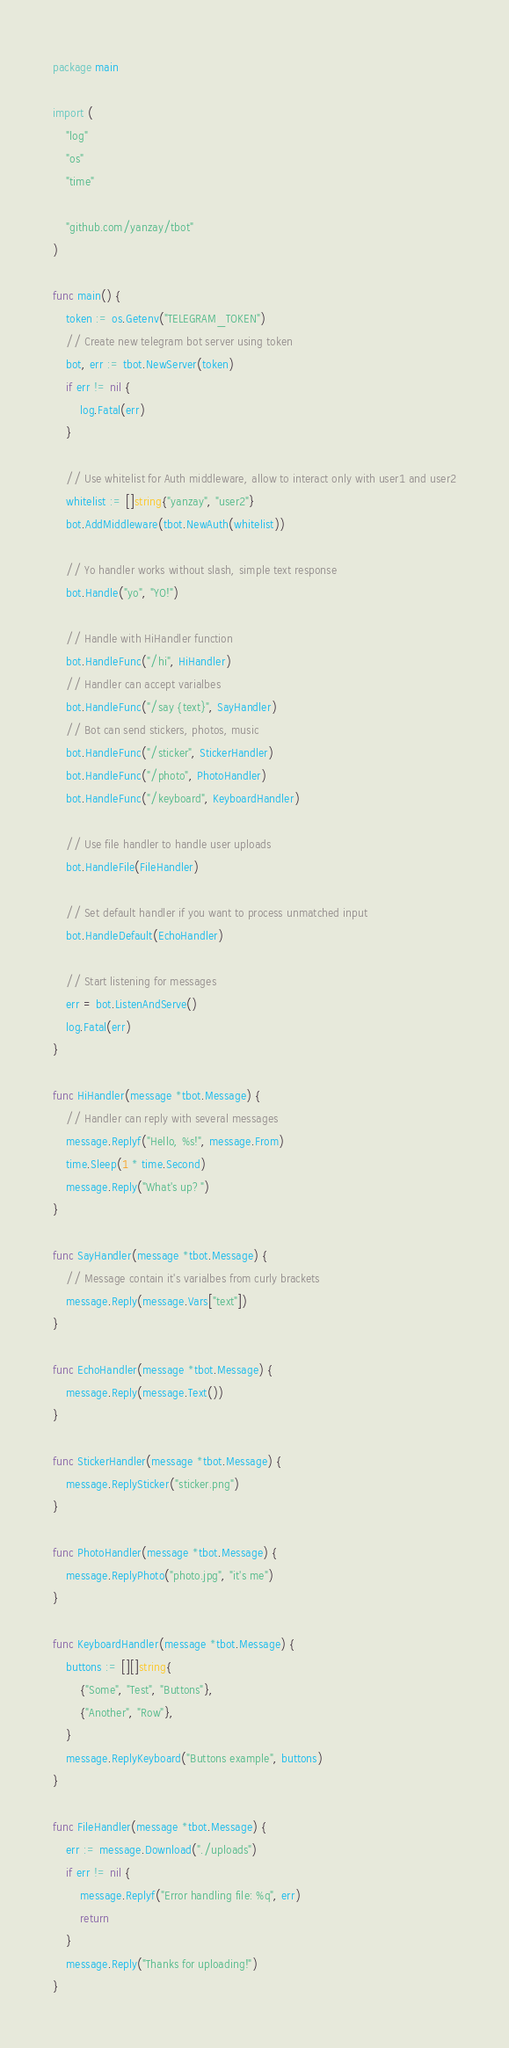Convert code to text. <code><loc_0><loc_0><loc_500><loc_500><_Go_>package main

import (
	"log"
	"os"
	"time"

	"github.com/yanzay/tbot"
)

func main() {
	token := os.Getenv("TELEGRAM_TOKEN")
	// Create new telegram bot server using token
	bot, err := tbot.NewServer(token)
	if err != nil {
		log.Fatal(err)
	}

	// Use whitelist for Auth middleware, allow to interact only with user1 and user2
	whitelist := []string{"yanzay", "user2"}
	bot.AddMiddleware(tbot.NewAuth(whitelist))

	// Yo handler works without slash, simple text response
	bot.Handle("yo", "YO!")

	// Handle with HiHandler function
	bot.HandleFunc("/hi", HiHandler)
	// Handler can accept varialbes
	bot.HandleFunc("/say {text}", SayHandler)
	// Bot can send stickers, photos, music
	bot.HandleFunc("/sticker", StickerHandler)
	bot.HandleFunc("/photo", PhotoHandler)
	bot.HandleFunc("/keyboard", KeyboardHandler)

	// Use file handler to handle user uploads
	bot.HandleFile(FileHandler)

	// Set default handler if you want to process unmatched input
	bot.HandleDefault(EchoHandler)

	// Start listening for messages
	err = bot.ListenAndServe()
	log.Fatal(err)
}

func HiHandler(message *tbot.Message) {
	// Handler can reply with several messages
	message.Replyf("Hello, %s!", message.From)
	time.Sleep(1 * time.Second)
	message.Reply("What's up?")
}

func SayHandler(message *tbot.Message) {
	// Message contain it's varialbes from curly brackets
	message.Reply(message.Vars["text"])
}

func EchoHandler(message *tbot.Message) {
	message.Reply(message.Text())
}

func StickerHandler(message *tbot.Message) {
	message.ReplySticker("sticker.png")
}

func PhotoHandler(message *tbot.Message) {
	message.ReplyPhoto("photo.jpg", "it's me")
}

func KeyboardHandler(message *tbot.Message) {
	buttons := [][]string{
		{"Some", "Test", "Buttons"},
		{"Another", "Row"},
	}
	message.ReplyKeyboard("Buttons example", buttons)
}

func FileHandler(message *tbot.Message) {
	err := message.Download("./uploads")
	if err != nil {
		message.Replyf("Error handling file: %q", err)
		return
	}
	message.Reply("Thanks for uploading!")
}
</code> 